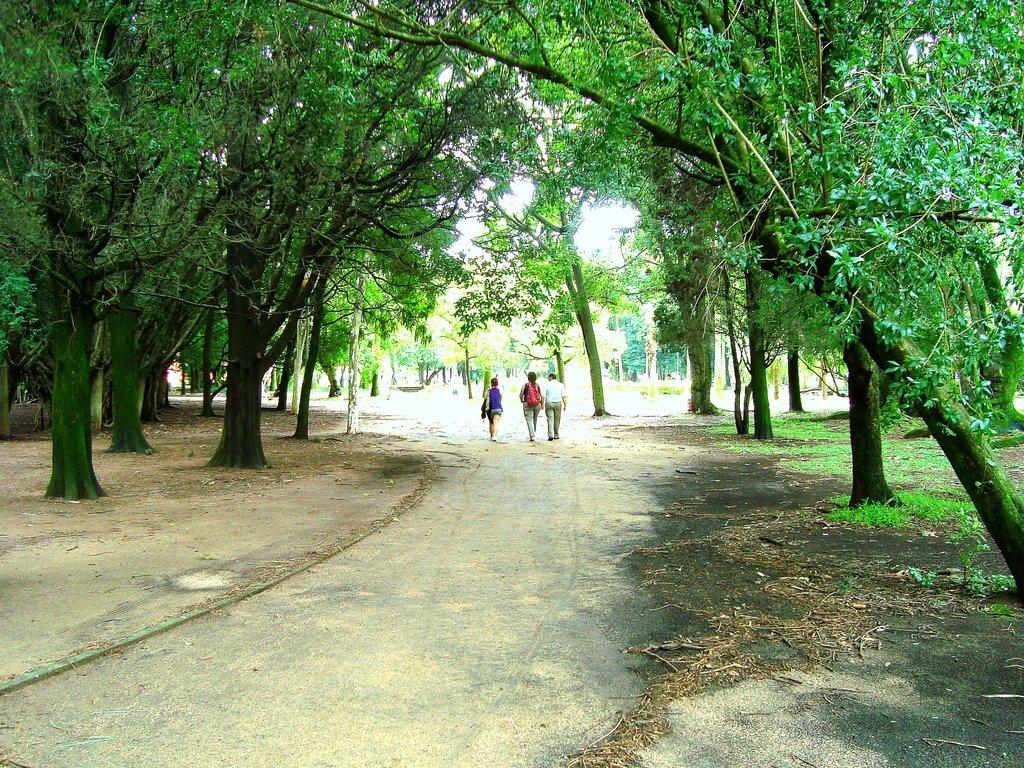How many people are in the image? There are three persons in the image. What are the persons doing in the image? The persons are walking on the road. What can be seen on both sides of the road in the image? There are trees on the left side and the right side of the image. What type of mark can be seen on the street in the image? There is no mark visible on the street in the image. What kind of drug is being sold by the persons in the image? There is no indication in the image that the persons are selling or using any drugs. 